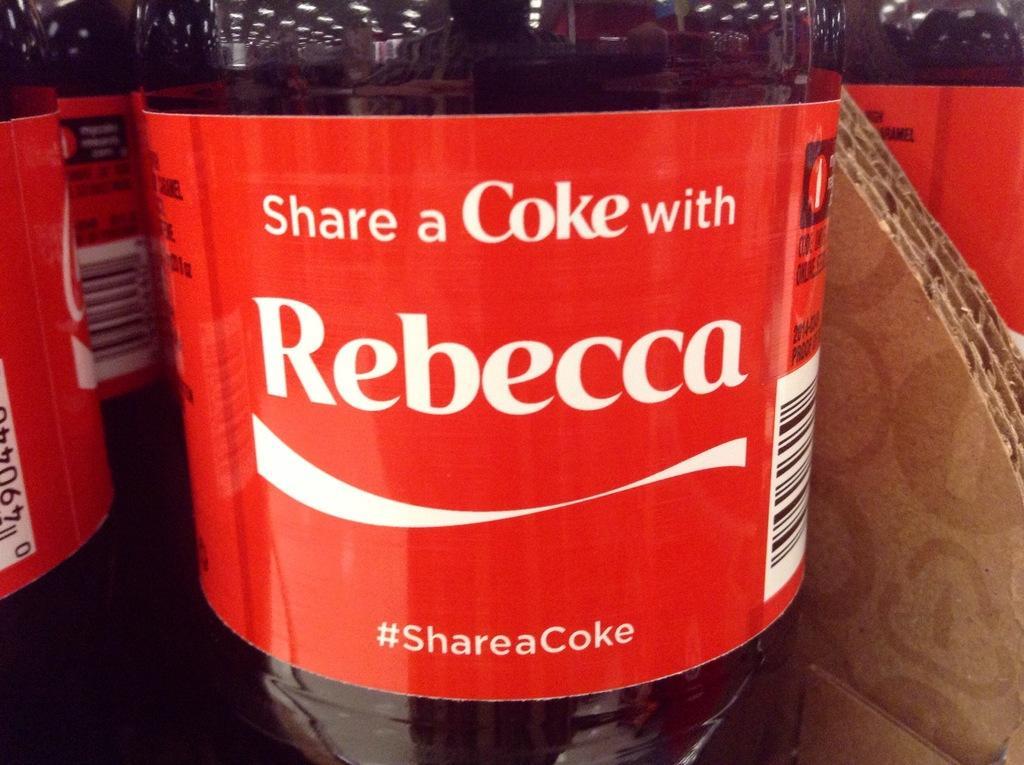Describe this image in one or two sentences. This image consists of a bottle, there are so many bottles. And it is a rebecca cooke. There is a coke in the bottle. There is a cardboard beside that bottle. 